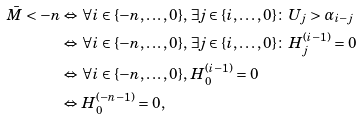<formula> <loc_0><loc_0><loc_500><loc_500>\bar { M } < - n & \Leftrightarrow \forall i \in \{ - n , \dots , 0 \} , \, \exists j \in \{ i , \dots , 0 \} \colon \, U _ { j } > \alpha _ { i - j } \\ & \Leftrightarrow \forall i \in \{ - n , \dots , 0 \} , \, \exists j \in \{ i , \dots , 0 \} \colon \, H ^ { ( i - 1 ) } _ { j } = 0 \\ & \Leftrightarrow \forall i \in \{ - n , \dots , 0 \} , \, H ^ { ( i - 1 ) } _ { 0 } = 0 \\ & \Leftrightarrow H ^ { ( - n - 1 ) } _ { 0 } = 0 ,</formula> 